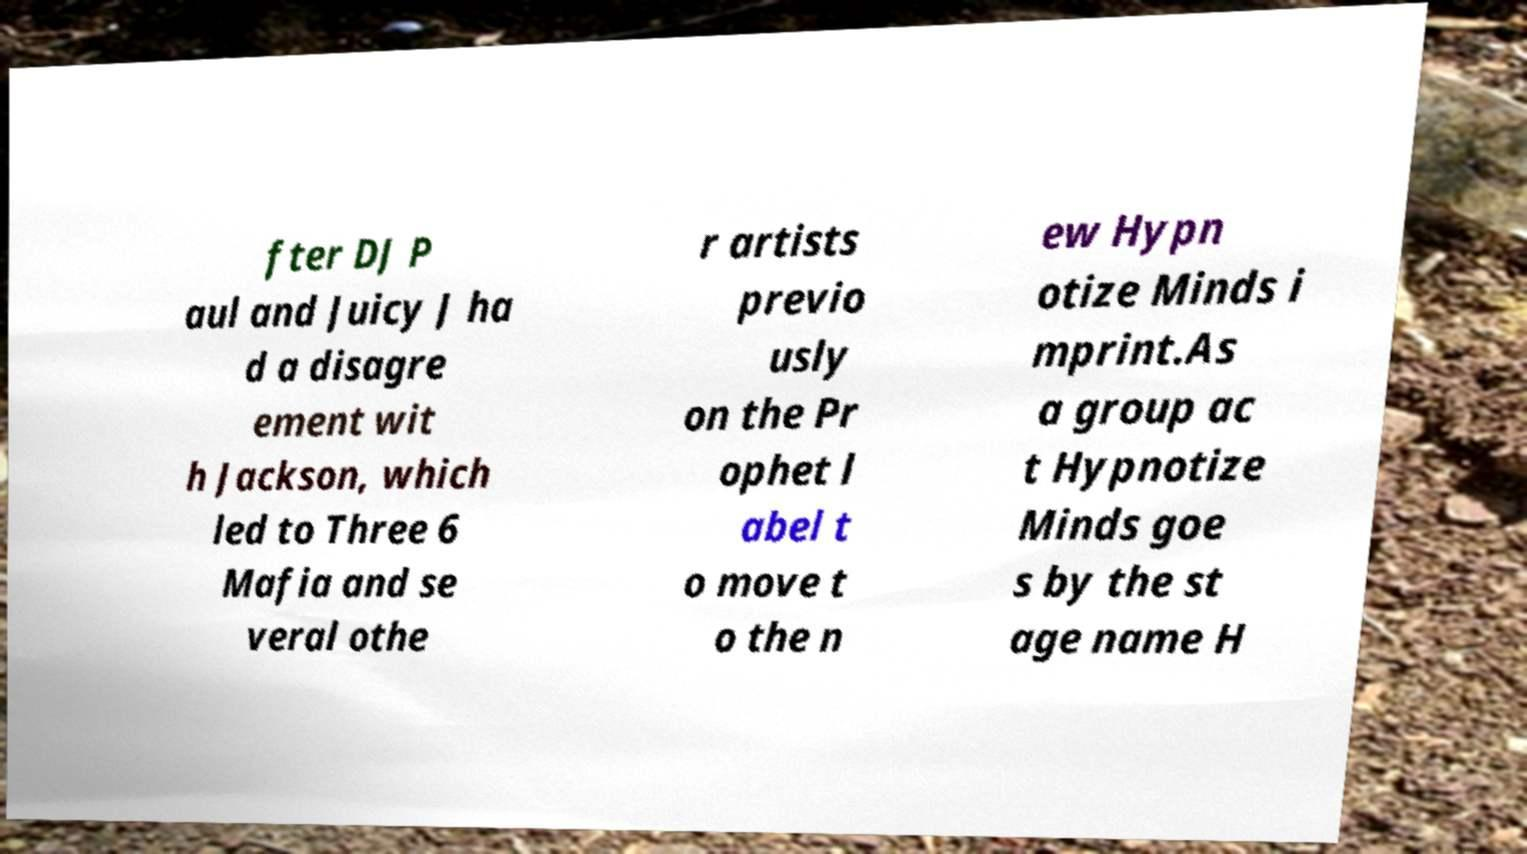Please identify and transcribe the text found in this image. fter DJ P aul and Juicy J ha d a disagre ement wit h Jackson, which led to Three 6 Mafia and se veral othe r artists previo usly on the Pr ophet l abel t o move t o the n ew Hypn otize Minds i mprint.As a group ac t Hypnotize Minds goe s by the st age name H 